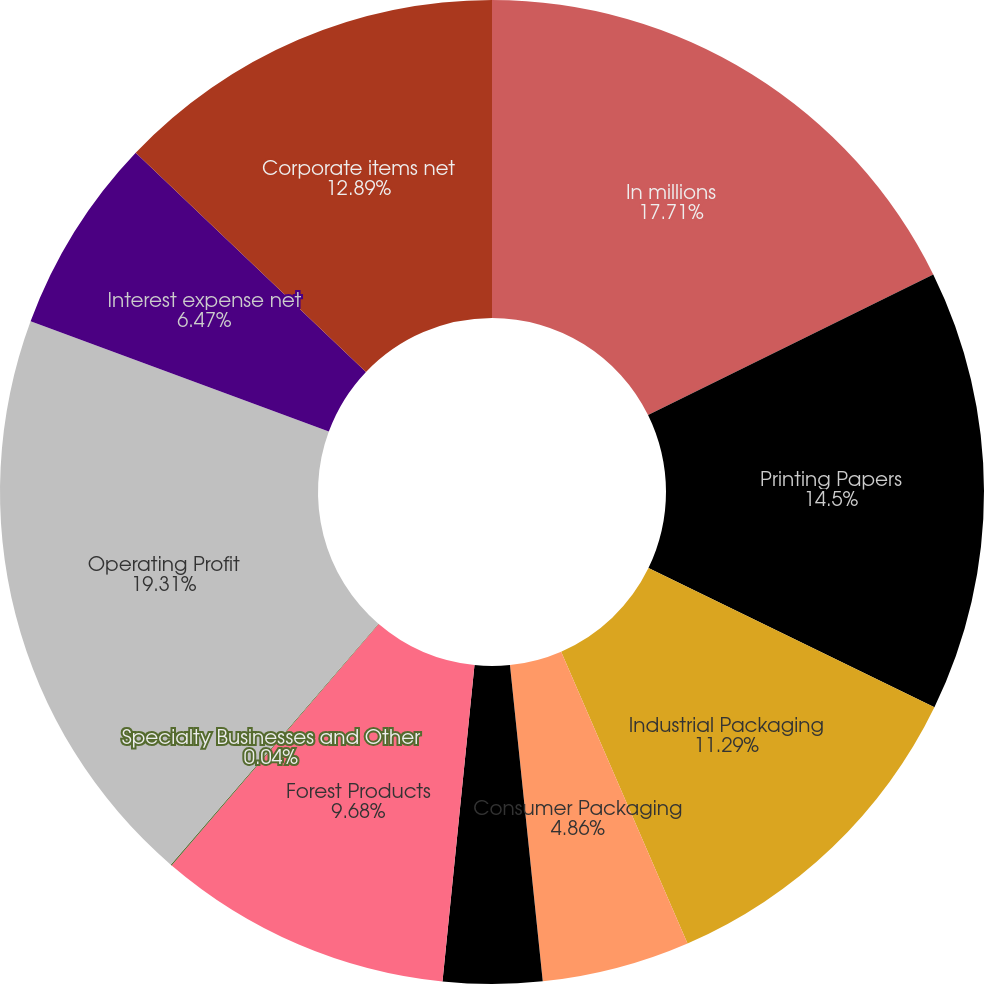<chart> <loc_0><loc_0><loc_500><loc_500><pie_chart><fcel>In millions<fcel>Printing Papers<fcel>Industrial Packaging<fcel>Consumer Packaging<fcel>Distribution<fcel>Forest Products<fcel>Specialty Businesses and Other<fcel>Operating Profit<fcel>Interest expense net<fcel>Corporate items net<nl><fcel>17.71%<fcel>14.5%<fcel>11.29%<fcel>4.86%<fcel>3.25%<fcel>9.68%<fcel>0.04%<fcel>19.32%<fcel>6.47%<fcel>12.89%<nl></chart> 